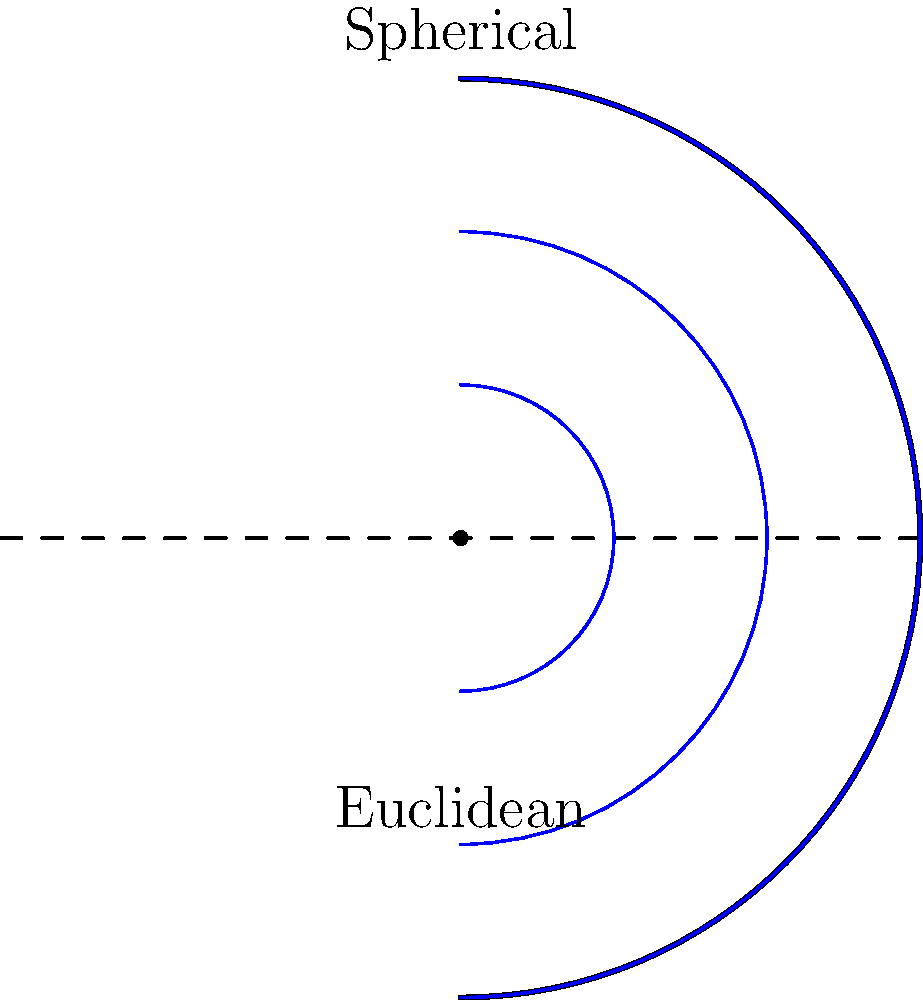In your experience as an interviewee for documentaries on mathematical concepts, how would you explain the difference in distance measurement between Euclidean and non-Euclidean geometries using the concentric circles shown in the image? Can you provide a real-world analogy to make this concept more accessible to a general audience? To explain the difference in distance measurement between Euclidean and non-Euclidean geometries, we can follow these steps:

1. Euclidean geometry (flat surface):
   - In Euclidean geometry, distance is measured along straight lines.
   - The concentric circles would appear as evenly spaced rings on a flat plane.
   - The distance between each circle would be constant.

2. Non-Euclidean geometry (curved surface, e.g., sphere):
   - In non-Euclidean geometry, distance is measured along curved paths.
   - The concentric circles on the sphere appear to be closer together as they move away from the center.
   - This is because the surface of the sphere curves, affecting how we perceive and measure distance.

3. Real-world analogy:
   - Imagine walking on the Earth's surface (approximated as a sphere).
   - If you start at the North Pole and walk along different longitudes, these paths will appear to be parallel and equidistant near the pole.
   - However, as you continue walking, these paths will converge at the South Pole, despite starting as "parallel" lines.

4. Implications:
   - In Euclidean geometry, parallel lines never meet.
   - In spherical geometry (a type of non-Euclidean geometry), "parallel" lines (like longitudes) can meet at poles.
   - This demonstrates how the underlying geometry affects our understanding of distance and parallel lines.

5. Connection to the image:
   - The blue arcs represent the concentric circles on a sphere.
   - The dashed line represents how these circles would appear in Euclidean geometry.
   - The difference in spacing between the arcs and the dashed line illustrates how distance is measured differently in these geometries.

By using the Earth as an example, we can help the audience visualize how geometric principles change when applied to curved surfaces, making the concept of non-Euclidean geometry more tangible and relatable.
Answer: Non-Euclidean geometries measure distances along curved paths, resulting in varying spacing between parallel lines, unlike the constant spacing in Euclidean geometry. 